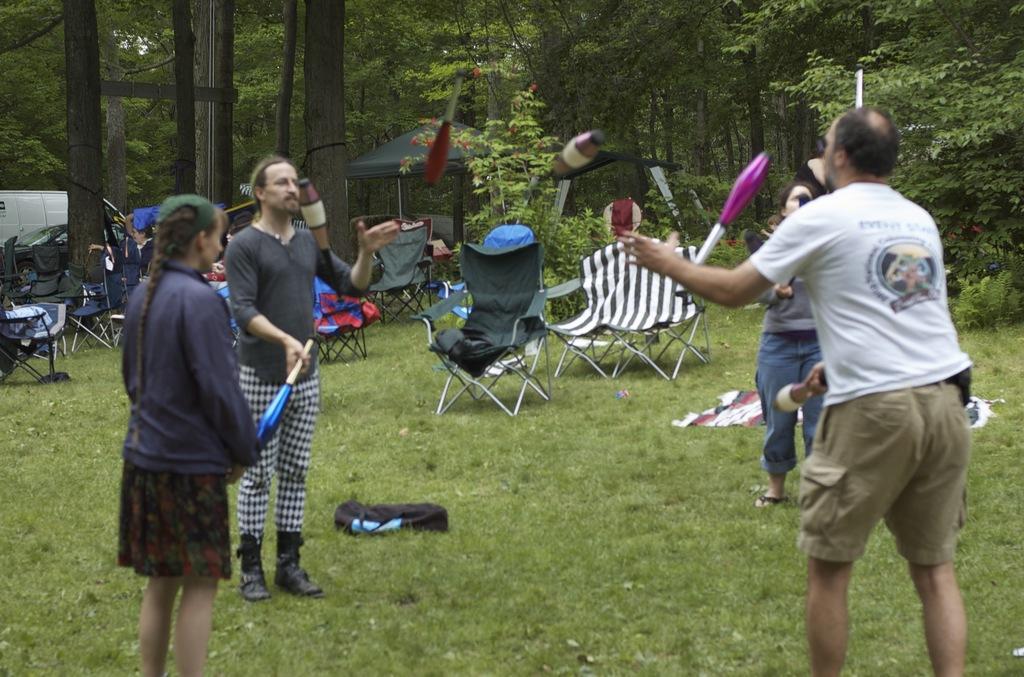Can you describe this image briefly? In the center of the image we can see people juggling. At the bottom of the image there is grass. In the background of the image there are trees, chairs. To the left side of the image there is a vehicle. In the center of the image there is a black color bag. 